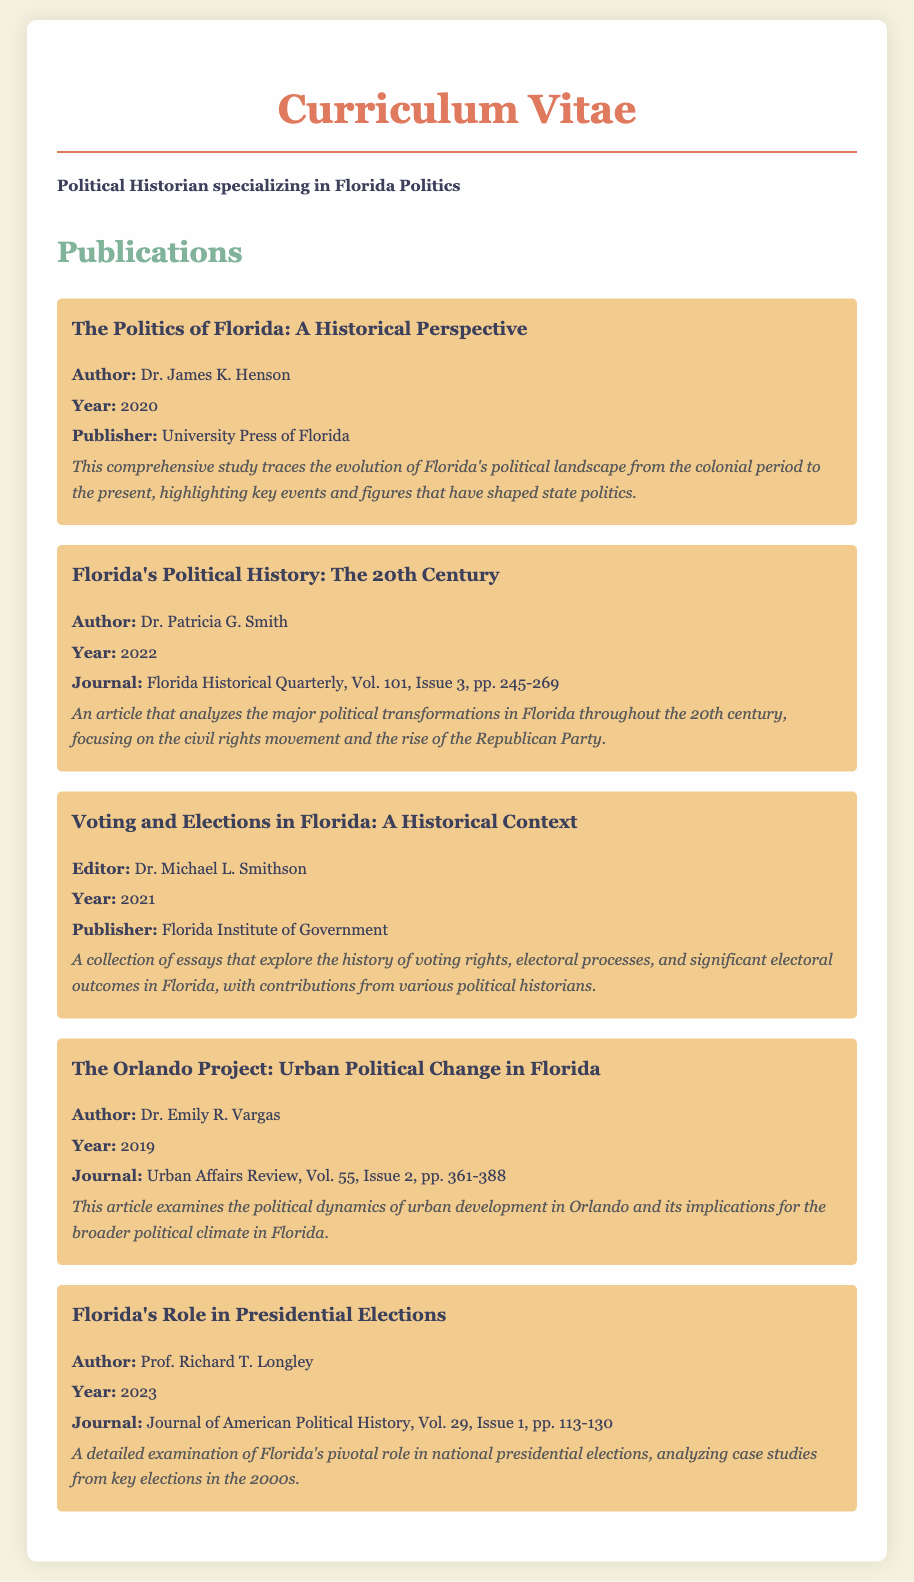What is the title of the publication by Dr. James K. Henson? The title is mentioned under his publications section, specifically detailing his work on Florida's political history.
Answer: The Politics of Florida: A Historical Perspective Who published "Florida's Political History: The 20th Century"? This information is included under the publication details where the author and publisher are specified.
Answer: Florida Historical Quarterly What year was "Voting and Elections in Florida: A Historical Context" published? The publication year is explicitly provided alongside the editor and publisher information for this collection of essays.
Answer: 2021 How many pages does "The Orlando Project: Urban Political Change in Florida" span? The page range is provided as part of the publication details in the journal citation.
Answer: pp. 361-388 Who is the author of "Florida's Role in Presidential Elections"? The document clearly identifies the author in relation to the title of this specific publication.
Answer: Prof. Richard T. Longley Which publication focuses on the civil rights movement within the context of Florida? This is deduced from the description related to political transformations in the 20th century.
Answer: Florida's Political History: The 20th Century How many publications are listed in the document? The total number of publications is revealed through the content of the Publications section.
Answer: Five What is the primary theme of the collection edited by Dr. Michael L. Smithson? The description of the collection explicitly outlines its focus regarding voting rights and electoral processes.
Answer: History of voting rights and electoral processes in Florida 